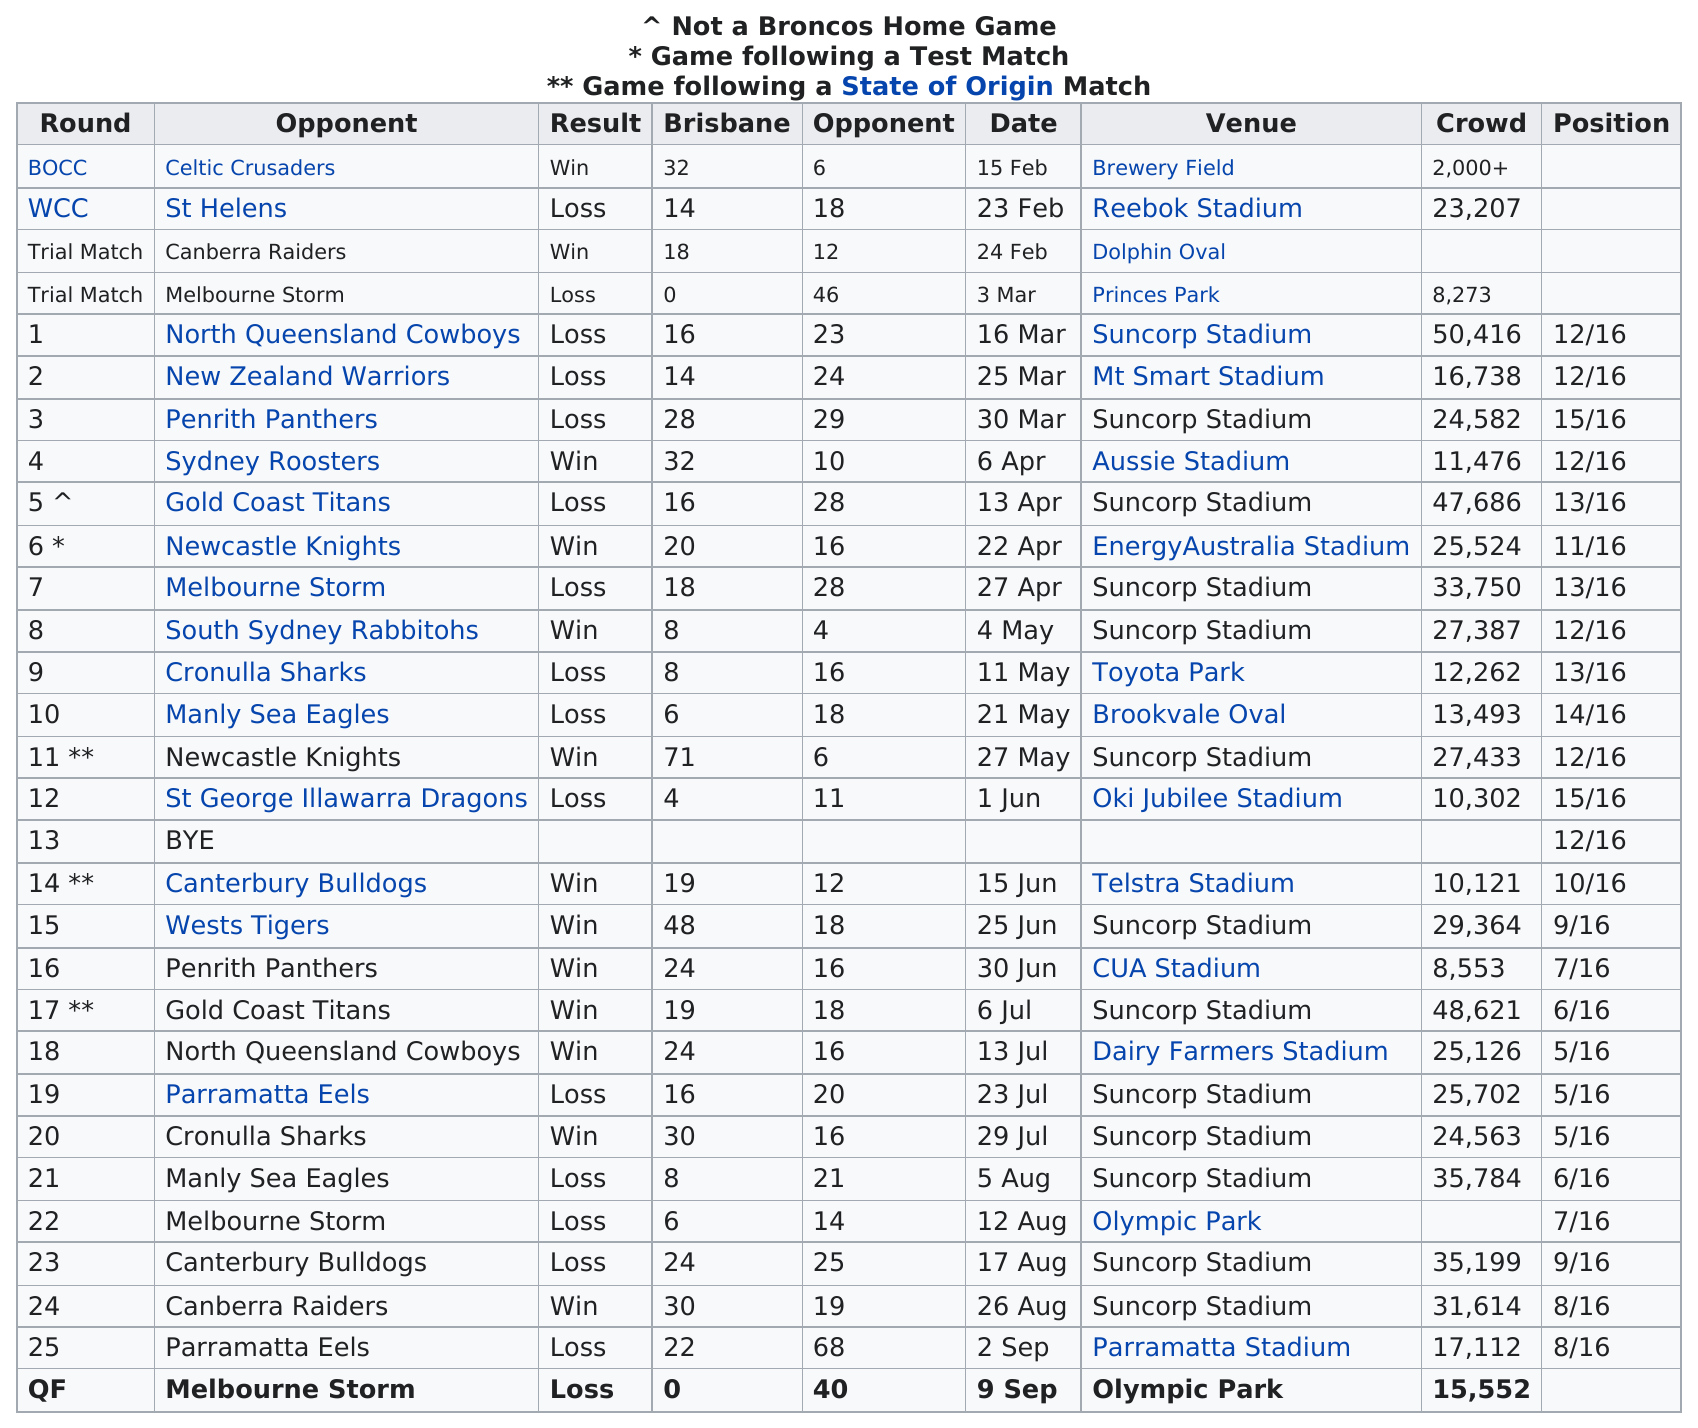Point out several critical features in this image. The North Queensland Cowboys were the opponents in the game that drew the largest crowd. The Brisbane Broncos last won a game before the end of the season against the Canberra Raiders. The Brisbane Broncos achieved the largest consecutive win streak of 5 games during the 2007 season, cementing their dominance on the field. Out of the 15 games played, 13 of them were held at Suncorp Stadium. On March 25th, the opponent after the New Zealand Warriors was the Penrith Panthers. 